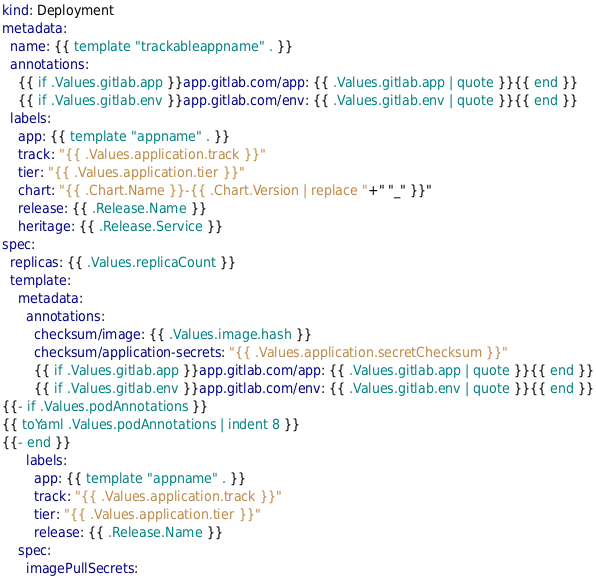Convert code to text. <code><loc_0><loc_0><loc_500><loc_500><_YAML_>kind: Deployment
metadata:
  name: {{ template "trackableappname" . }}
  annotations:
    {{ if .Values.gitlab.app }}app.gitlab.com/app: {{ .Values.gitlab.app | quote }}{{ end }}
    {{ if .Values.gitlab.env }}app.gitlab.com/env: {{ .Values.gitlab.env | quote }}{{ end }}
  labels:
    app: {{ template "appname" . }}
    track: "{{ .Values.application.track }}"
    tier: "{{ .Values.application.tier }}"
    chart: "{{ .Chart.Name }}-{{ .Chart.Version | replace "+" "_" }}"
    release: {{ .Release.Name }}
    heritage: {{ .Release.Service }}
spec:
  replicas: {{ .Values.replicaCount }}
  template:
    metadata:
      annotations:
        checksum/image: {{ .Values.image.hash }}
        checksum/application-secrets: "{{ .Values.application.secretChecksum }}"
        {{ if .Values.gitlab.app }}app.gitlab.com/app: {{ .Values.gitlab.app | quote }}{{ end }}
        {{ if .Values.gitlab.env }}app.gitlab.com/env: {{ .Values.gitlab.env | quote }}{{ end }}
{{- if .Values.podAnnotations }}
{{ toYaml .Values.podAnnotations | indent 8 }}
{{- end }}
      labels:
        app: {{ template "appname" . }}
        track: "{{ .Values.application.track }}"
        tier: "{{ .Values.application.tier }}"
        release: {{ .Release.Name }}
    spec:
      imagePullSecrets:</code> 